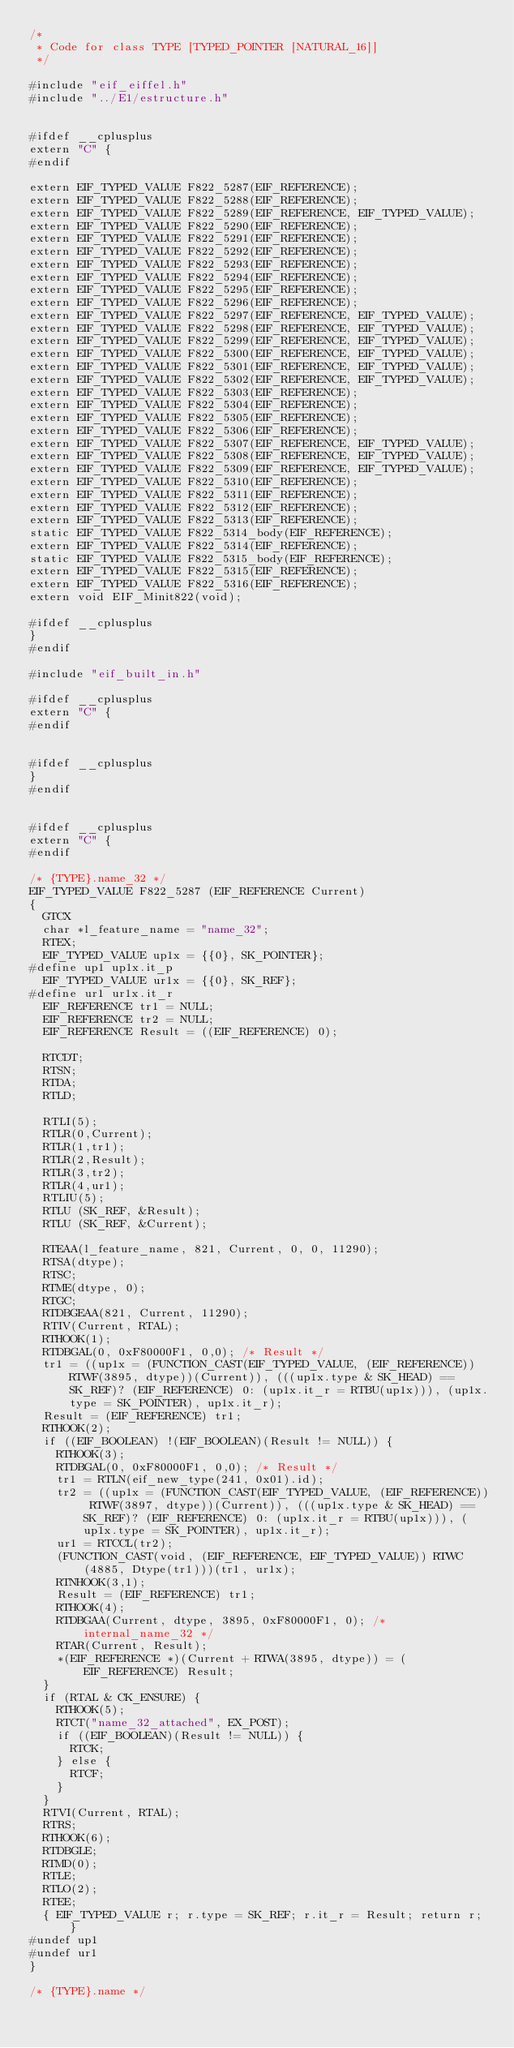Convert code to text. <code><loc_0><loc_0><loc_500><loc_500><_C_>/*
 * Code for class TYPE [TYPED_POINTER [NATURAL_16]]
 */

#include "eif_eiffel.h"
#include "../E1/estructure.h"


#ifdef __cplusplus
extern "C" {
#endif

extern EIF_TYPED_VALUE F822_5287(EIF_REFERENCE);
extern EIF_TYPED_VALUE F822_5288(EIF_REFERENCE);
extern EIF_TYPED_VALUE F822_5289(EIF_REFERENCE, EIF_TYPED_VALUE);
extern EIF_TYPED_VALUE F822_5290(EIF_REFERENCE);
extern EIF_TYPED_VALUE F822_5291(EIF_REFERENCE);
extern EIF_TYPED_VALUE F822_5292(EIF_REFERENCE);
extern EIF_TYPED_VALUE F822_5293(EIF_REFERENCE);
extern EIF_TYPED_VALUE F822_5294(EIF_REFERENCE);
extern EIF_TYPED_VALUE F822_5295(EIF_REFERENCE);
extern EIF_TYPED_VALUE F822_5296(EIF_REFERENCE);
extern EIF_TYPED_VALUE F822_5297(EIF_REFERENCE, EIF_TYPED_VALUE);
extern EIF_TYPED_VALUE F822_5298(EIF_REFERENCE, EIF_TYPED_VALUE);
extern EIF_TYPED_VALUE F822_5299(EIF_REFERENCE, EIF_TYPED_VALUE);
extern EIF_TYPED_VALUE F822_5300(EIF_REFERENCE, EIF_TYPED_VALUE);
extern EIF_TYPED_VALUE F822_5301(EIF_REFERENCE, EIF_TYPED_VALUE);
extern EIF_TYPED_VALUE F822_5302(EIF_REFERENCE, EIF_TYPED_VALUE);
extern EIF_TYPED_VALUE F822_5303(EIF_REFERENCE);
extern EIF_TYPED_VALUE F822_5304(EIF_REFERENCE);
extern EIF_TYPED_VALUE F822_5305(EIF_REFERENCE);
extern EIF_TYPED_VALUE F822_5306(EIF_REFERENCE);
extern EIF_TYPED_VALUE F822_5307(EIF_REFERENCE, EIF_TYPED_VALUE);
extern EIF_TYPED_VALUE F822_5308(EIF_REFERENCE, EIF_TYPED_VALUE);
extern EIF_TYPED_VALUE F822_5309(EIF_REFERENCE, EIF_TYPED_VALUE);
extern EIF_TYPED_VALUE F822_5310(EIF_REFERENCE);
extern EIF_TYPED_VALUE F822_5311(EIF_REFERENCE);
extern EIF_TYPED_VALUE F822_5312(EIF_REFERENCE);
extern EIF_TYPED_VALUE F822_5313(EIF_REFERENCE);
static EIF_TYPED_VALUE F822_5314_body(EIF_REFERENCE);
extern EIF_TYPED_VALUE F822_5314(EIF_REFERENCE);
static EIF_TYPED_VALUE F822_5315_body(EIF_REFERENCE);
extern EIF_TYPED_VALUE F822_5315(EIF_REFERENCE);
extern EIF_TYPED_VALUE F822_5316(EIF_REFERENCE);
extern void EIF_Minit822(void);

#ifdef __cplusplus
}
#endif

#include "eif_built_in.h"

#ifdef __cplusplus
extern "C" {
#endif


#ifdef __cplusplus
}
#endif


#ifdef __cplusplus
extern "C" {
#endif

/* {TYPE}.name_32 */
EIF_TYPED_VALUE F822_5287 (EIF_REFERENCE Current)
{
	GTCX
	char *l_feature_name = "name_32";
	RTEX;
	EIF_TYPED_VALUE up1x = {{0}, SK_POINTER};
#define up1 up1x.it_p
	EIF_TYPED_VALUE ur1x = {{0}, SK_REF};
#define ur1 ur1x.it_r
	EIF_REFERENCE tr1 = NULL;
	EIF_REFERENCE tr2 = NULL;
	EIF_REFERENCE Result = ((EIF_REFERENCE) 0);
	
	RTCDT;
	RTSN;
	RTDA;
	RTLD;
	
	RTLI(5);
	RTLR(0,Current);
	RTLR(1,tr1);
	RTLR(2,Result);
	RTLR(3,tr2);
	RTLR(4,ur1);
	RTLIU(5);
	RTLU (SK_REF, &Result);
	RTLU (SK_REF, &Current);
	
	RTEAA(l_feature_name, 821, Current, 0, 0, 11290);
	RTSA(dtype);
	RTSC;
	RTME(dtype, 0);
	RTGC;
	RTDBGEAA(821, Current, 11290);
	RTIV(Current, RTAL);
	RTHOOK(1);
	RTDBGAL(0, 0xF80000F1, 0,0); /* Result */
	tr1 = ((up1x = (FUNCTION_CAST(EIF_TYPED_VALUE, (EIF_REFERENCE)) RTWF(3895, dtype))(Current)), (((up1x.type & SK_HEAD) == SK_REF)? (EIF_REFERENCE) 0: (up1x.it_r = RTBU(up1x))), (up1x.type = SK_POINTER), up1x.it_r);
	Result = (EIF_REFERENCE) tr1;
	RTHOOK(2);
	if ((EIF_BOOLEAN) !(EIF_BOOLEAN)(Result != NULL)) {
		RTHOOK(3);
		RTDBGAL(0, 0xF80000F1, 0,0); /* Result */
		tr1 = RTLN(eif_new_type(241, 0x01).id);
		tr2 = ((up1x = (FUNCTION_CAST(EIF_TYPED_VALUE, (EIF_REFERENCE)) RTWF(3897, dtype))(Current)), (((up1x.type & SK_HEAD) == SK_REF)? (EIF_REFERENCE) 0: (up1x.it_r = RTBU(up1x))), (up1x.type = SK_POINTER), up1x.it_r);
		ur1 = RTCCL(tr2);
		(FUNCTION_CAST(void, (EIF_REFERENCE, EIF_TYPED_VALUE)) RTWC(4885, Dtype(tr1)))(tr1, ur1x);
		RTNHOOK(3,1);
		Result = (EIF_REFERENCE) tr1;
		RTHOOK(4);
		RTDBGAA(Current, dtype, 3895, 0xF80000F1, 0); /* internal_name_32 */
		RTAR(Current, Result);
		*(EIF_REFERENCE *)(Current + RTWA(3895, dtype)) = (EIF_REFERENCE) Result;
	}
	if (RTAL & CK_ENSURE) {
		RTHOOK(5);
		RTCT("name_32_attached", EX_POST);
		if ((EIF_BOOLEAN)(Result != NULL)) {
			RTCK;
		} else {
			RTCF;
		}
	}
	RTVI(Current, RTAL);
	RTRS;
	RTHOOK(6);
	RTDBGLE;
	RTMD(0);
	RTLE;
	RTLO(2);
	RTEE;
	{ EIF_TYPED_VALUE r; r.type = SK_REF; r.it_r = Result; return r; }
#undef up1
#undef ur1
}

/* {TYPE}.name */</code> 